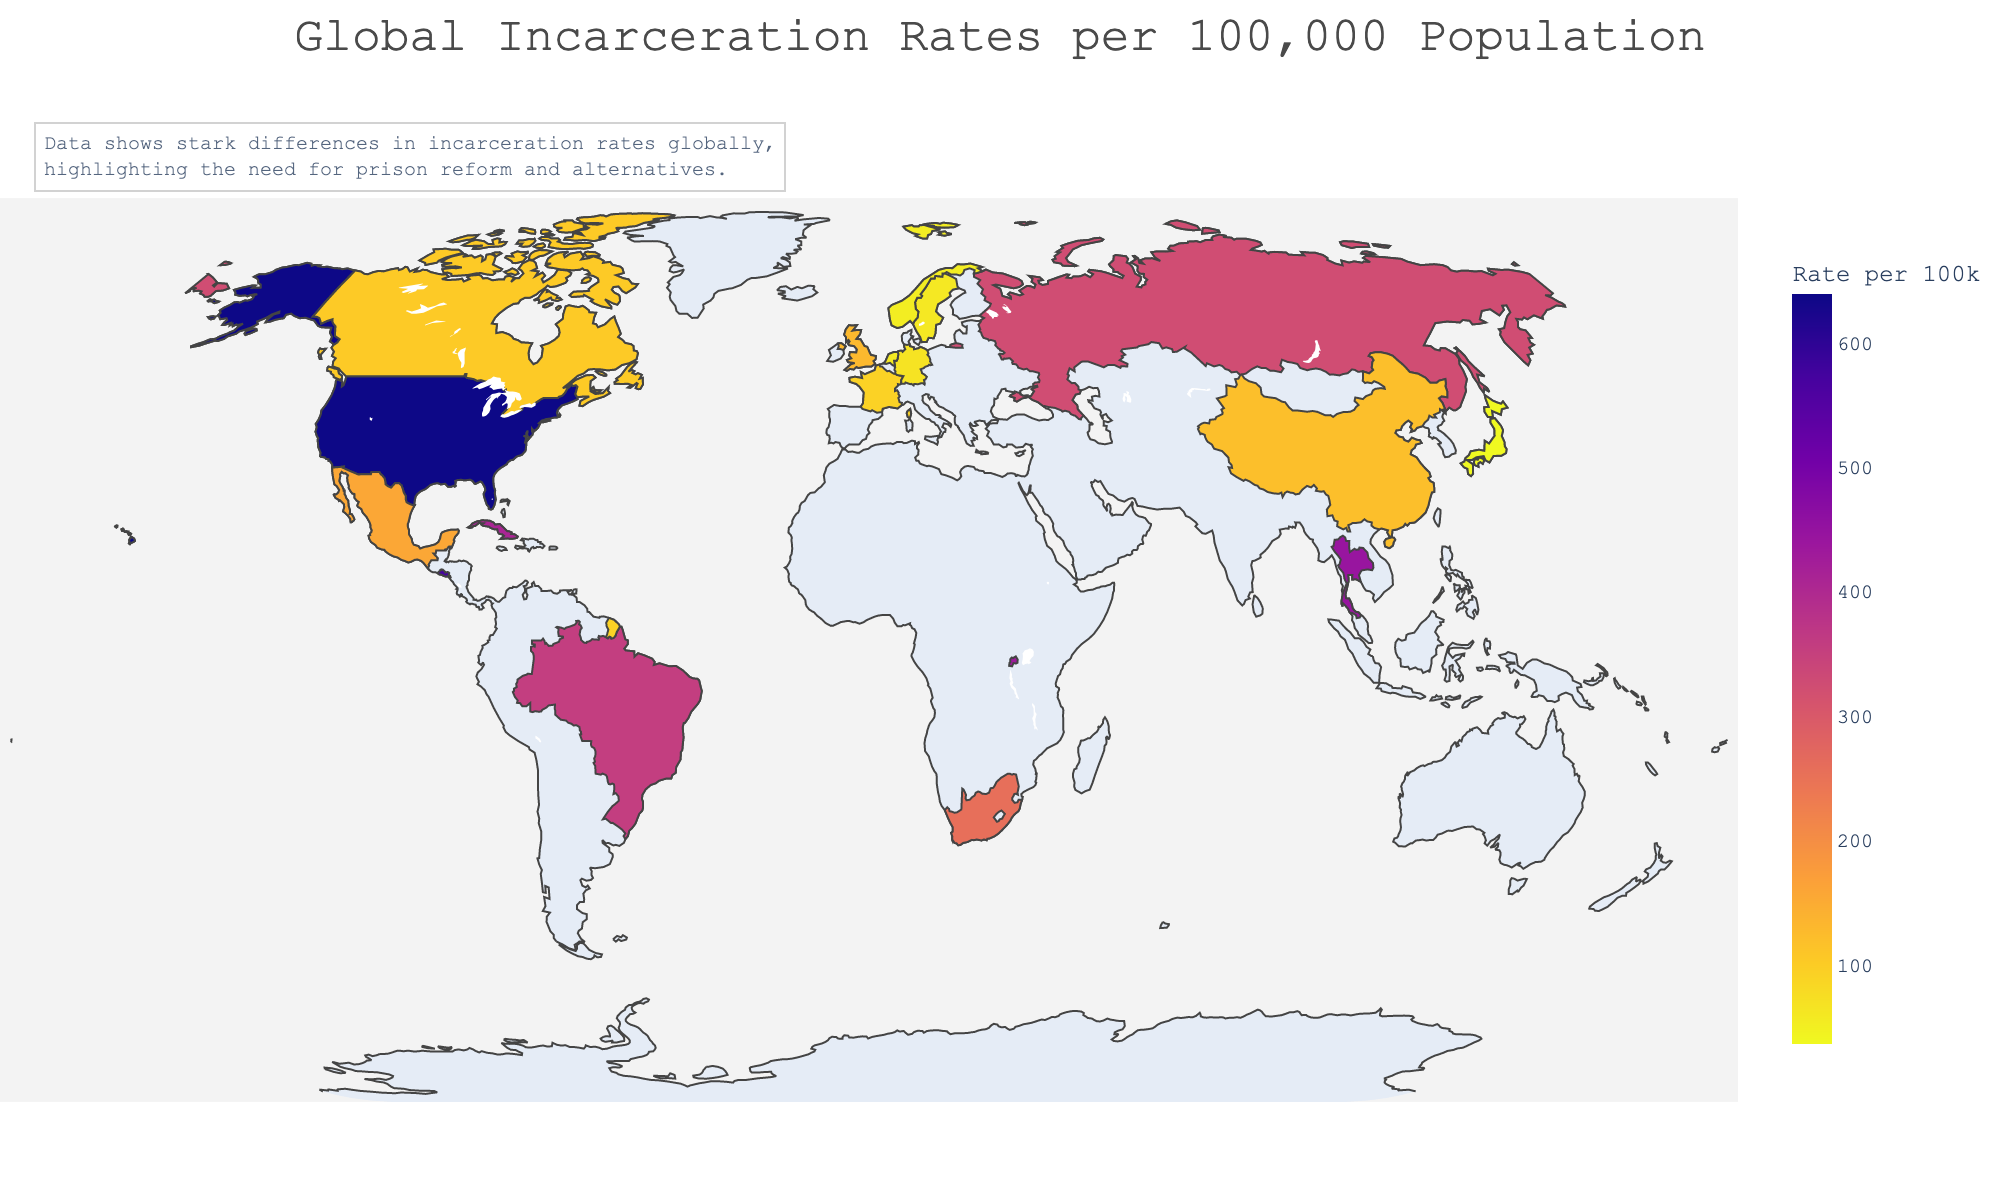What is the title of the figure? The title is usually located at the top of the figure and gives a summary of what the data represents. In this case, it is specified in the code as well.
Answer: Global Incarceration Rates per 100,000 Population Which country has the highest incarceration rate? Scan the plot to identify the country with the darkest color shading which represents the highest value on the color scale. In this case, the provided data shows the United States has the highest rate.
Answer: United States How does the incarceration rate in the United Kingdom compare to that of Canada? Locate the United Kingdom and Canada on the map and compare their color shades. Additionally, refer to the data where the United Kingdom has a rate of 130 and Canada has a rate of 104.
Answer: The United Kingdom has a higher rate than Canada What's the average incarceration rate for the top five countries? First, note the rates of the top five countries: United States (639), El Salvador (572), Thailand (445), Rwanda (434), and Cuba (410). Then calculate the average: (639 + 572 + 445 + 434 + 410) / 5 = 2500 / 5 = 500.
Answer: 500 Which country has a lower incarceration rate, France or Germany? Refer to the colors for France and Germany, and also the data provided. France has a rate of 93, and Germany has a rate of 69.
Answer: Germany How many countries have an incarceration rate below 100? Identify and count the countries with shades representing rates below 100 on the map. Referring to the provided data, these countries are China, Canada, France, Germany, Japan, Netherlands, Sweden, and Norway, totaling 8 countries.
Answer: 8 What is the difference in incarceration rates between Brazil and Mexico? Refer to the data where Brazil's rate is 357 and Mexico's rate is 158. Calculate the difference: 357 - 158 = 199.
Answer: 199 Which region appears to have the highest concentration of countries with high incarceration rates? Look at the map to see which geographic region has the darkest shades. From the given data, it is evident that the Americas have a high concentration of countries with high rates, specifically the United States, El Salvador, and Brazil.
Answer: The Americas Is Japan's incarceration rate higher or lower than the global average rate depicted in the figure? Calculate the global average from the provided data. [(639 + 572 + 445 + 434 + 410 + 357 + 325 + 258 + 158 + 130 + 121 + 104 + 93 + 69 + 37 + 59 + 61 + 54) / 18] ≈ 224.44. Japan's rate is 37.
Answer: Lower What can be inferred about the need for prison reform from the annotation and the spread of data? The annotation states that there are stark differences, implying inequality in incarceration rates and thus highlighting the need for prison reform worldwide where both high and low rates exist.
Answer: Stark differences suggest a need for prison reform globally 